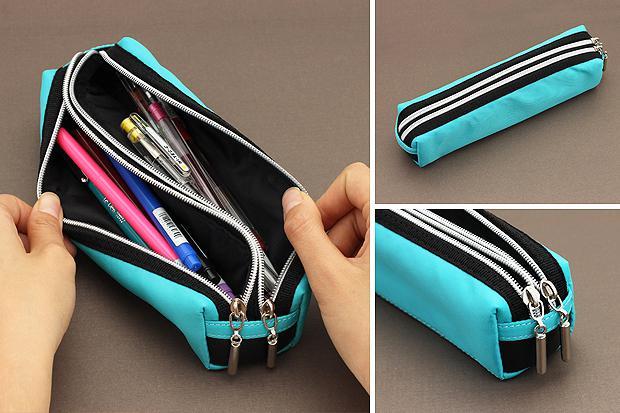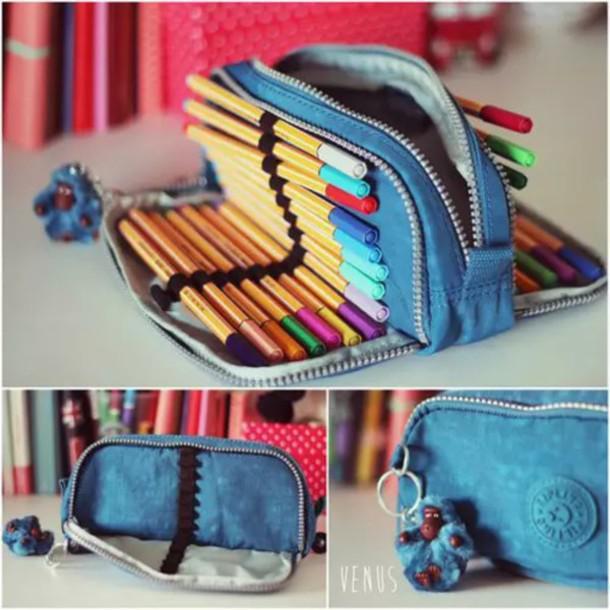The first image is the image on the left, the second image is the image on the right. For the images displayed, is the sentence "There is a human hand touching a pencil case in one of the images." factually correct? Answer yes or no. Yes. The first image is the image on the left, the second image is the image on the right. Examine the images to the left and right. Is the description "The left-hand image shows a double-zipper topped pencil case featuring sky-blue color." accurate? Answer yes or no. Yes. 